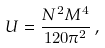<formula> <loc_0><loc_0><loc_500><loc_500>U = \frac { N ^ { 2 } M ^ { 4 } } { 1 2 0 \pi ^ { 2 } } \, ,</formula> 